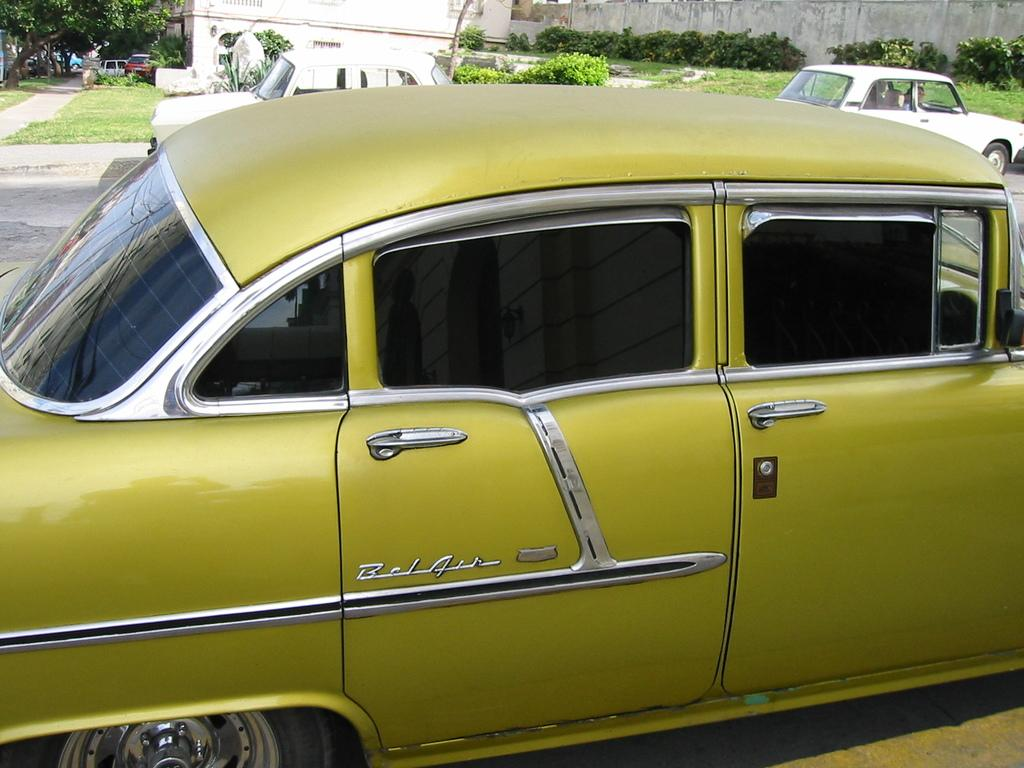What can be seen moving on the road in the image? There are cars on the road in the image. What structure is located at the top of the image? There is a building at the top of the image. What type of vegetation is in front of the wall in the image? There are plants in front of the wall in the image. Where is the tree located in the image? There is a tree in the top left of the image. Reasoning: Let' Let's think step by step in order to produce the conversation. We start by identifying the main subjects and objects in the image based on the provided facts. We then formulate questions that focus on the location and characteristics of these subjects and objects, ensuring that each question can be answered definitively with the information given. We avoid yes/no questions and ensure that the language is simple and clear. Absurd Question/Answer: What type of spark can be seen coming from the tree in the image? There is no spark present in the image; it only shows a tree in the top left corner. How many potatoes are visible in the image? There are no potatoes present in the image. What type of spark can be seen coming from the tree in the image? There is no spark present in the image; it only shows a tree in the top left corner. How many potatoes are visible in the image? There are no potatoes present in the image. 